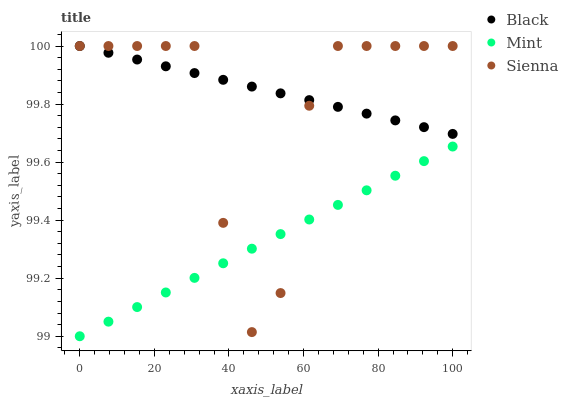Does Mint have the minimum area under the curve?
Answer yes or no. Yes. Does Black have the maximum area under the curve?
Answer yes or no. Yes. Does Black have the minimum area under the curve?
Answer yes or no. No. Does Mint have the maximum area under the curve?
Answer yes or no. No. Is Mint the smoothest?
Answer yes or no. Yes. Is Sienna the roughest?
Answer yes or no. Yes. Is Black the smoothest?
Answer yes or no. No. Is Black the roughest?
Answer yes or no. No. Does Mint have the lowest value?
Answer yes or no. Yes. Does Black have the lowest value?
Answer yes or no. No. Does Black have the highest value?
Answer yes or no. Yes. Does Mint have the highest value?
Answer yes or no. No. Is Mint less than Black?
Answer yes or no. Yes. Is Black greater than Mint?
Answer yes or no. Yes. Does Sienna intersect Mint?
Answer yes or no. Yes. Is Sienna less than Mint?
Answer yes or no. No. Is Sienna greater than Mint?
Answer yes or no. No. Does Mint intersect Black?
Answer yes or no. No. 